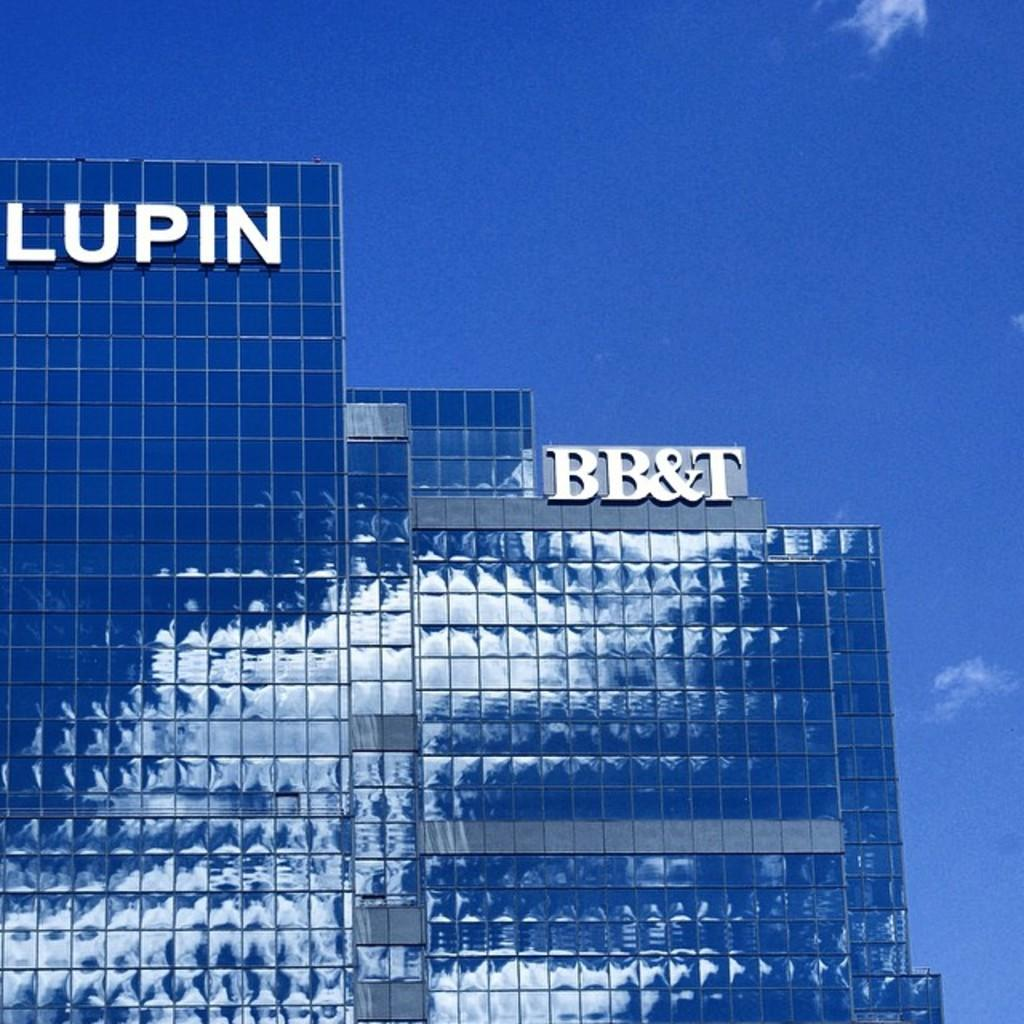What type of structures are present in the image? There are buildings in the image. Can you describe any additional features on the buildings? Yes, there is text written on the buildings. What can be seen in the background of the image? The sky is visible in the image. Where is the library located in the image? There is no library mentioned or visible in the image. 